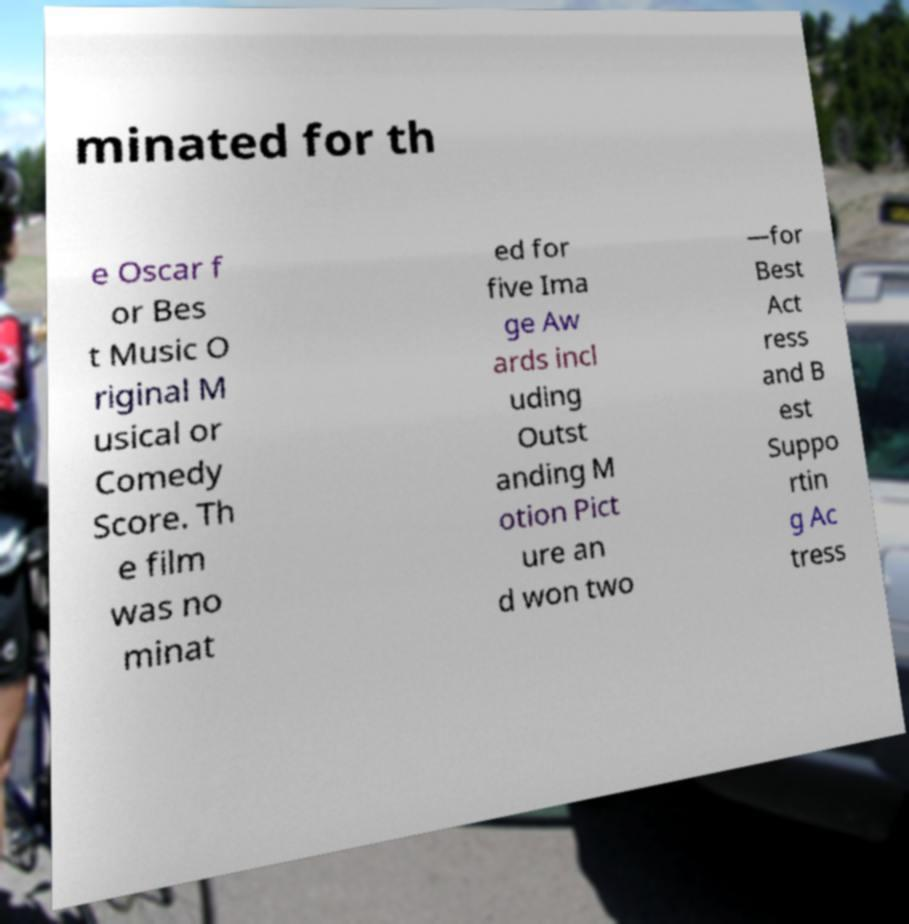I need the written content from this picture converted into text. Can you do that? minated for th e Oscar f or Bes t Music O riginal M usical or Comedy Score. Th e film was no minat ed for five Ima ge Aw ards incl uding Outst anding M otion Pict ure an d won two —for Best Act ress and B est Suppo rtin g Ac tress 